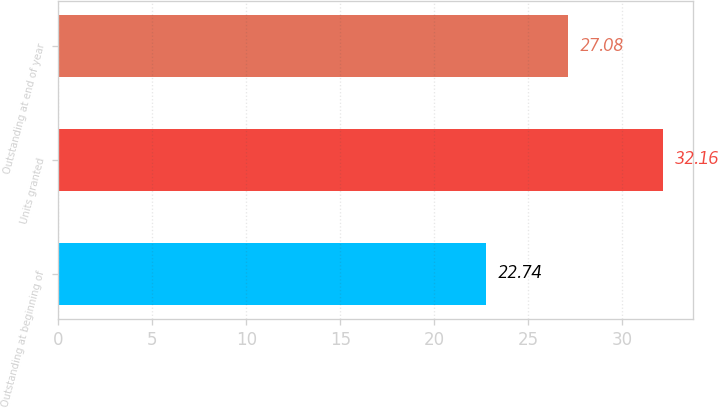Convert chart to OTSL. <chart><loc_0><loc_0><loc_500><loc_500><bar_chart><fcel>Outstanding at beginning of<fcel>Units granted<fcel>Outstanding at end of year<nl><fcel>22.74<fcel>32.16<fcel>27.08<nl></chart> 